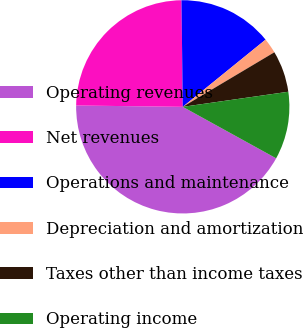<chart> <loc_0><loc_0><loc_500><loc_500><pie_chart><fcel>Operating revenues<fcel>Net revenues<fcel>Operations and maintenance<fcel>Depreciation and amortization<fcel>Taxes other than income taxes<fcel>Operating income<nl><fcel>42.18%<fcel>24.61%<fcel>14.34%<fcel>2.3%<fcel>6.29%<fcel>10.28%<nl></chart> 